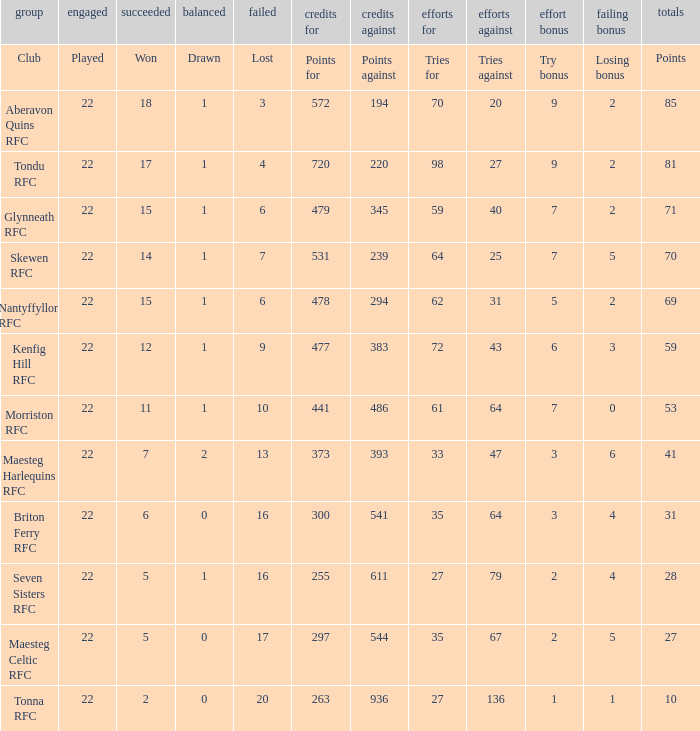What club got 239 points against? Skewen RFC. 